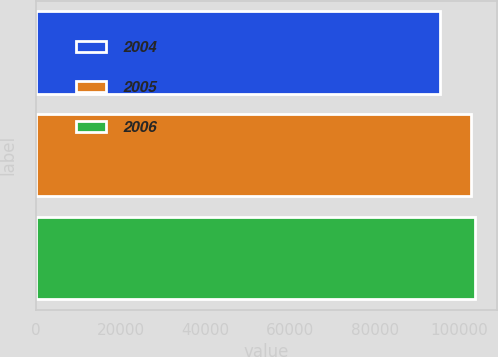<chart> <loc_0><loc_0><loc_500><loc_500><bar_chart><fcel>2004<fcel>2005<fcel>2006<nl><fcel>95303<fcel>102710<fcel>103614<nl></chart> 